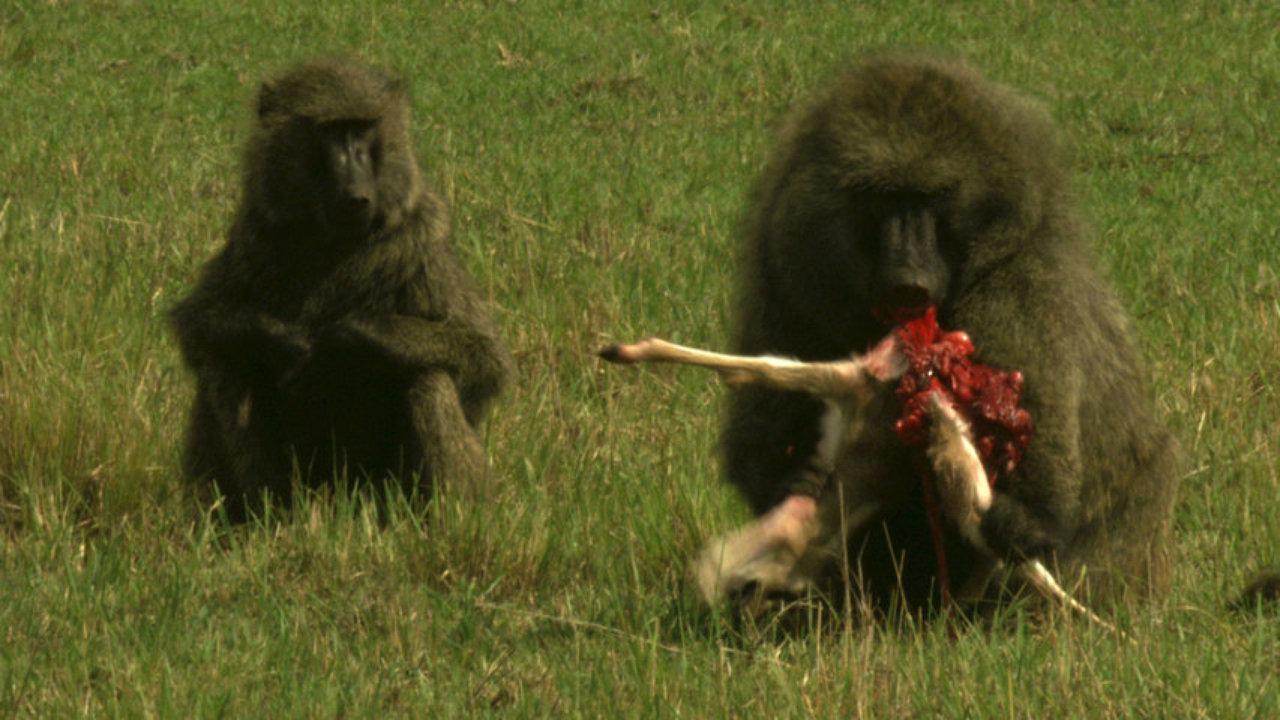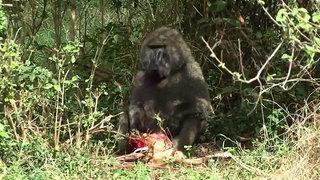The first image is the image on the left, the second image is the image on the right. Considering the images on both sides, is "There are exactly two baboons in at least one of the images." valid? Answer yes or no. Yes. The first image is the image on the left, the second image is the image on the right. Evaluate the accuracy of this statement regarding the images: "The image on the left contains no less than two baboons sitting in a grassy field.". Is it true? Answer yes or no. Yes. 